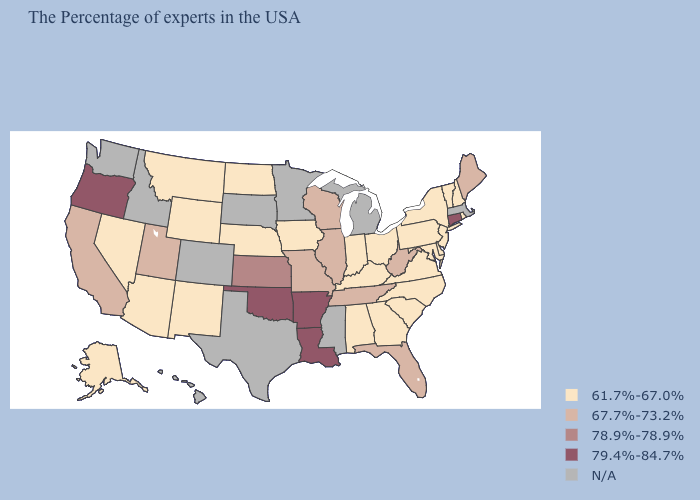Is the legend a continuous bar?
Give a very brief answer. No. Among the states that border Minnesota , does Wisconsin have the highest value?
Answer briefly. Yes. Does the first symbol in the legend represent the smallest category?
Answer briefly. Yes. Among the states that border Illinois , does Indiana have the lowest value?
Short answer required. Yes. Is the legend a continuous bar?
Keep it brief. No. Among the states that border Ohio , does West Virginia have the highest value?
Short answer required. Yes. Does Tennessee have the lowest value in the South?
Short answer required. No. What is the lowest value in states that border South Dakota?
Write a very short answer. 61.7%-67.0%. How many symbols are there in the legend?
Write a very short answer. 5. Among the states that border Iowa , which have the highest value?
Write a very short answer. Wisconsin, Illinois, Missouri. Which states hav the highest value in the West?
Short answer required. Oregon. Name the states that have a value in the range N/A?
Be succinct. Massachusetts, Michigan, Mississippi, Minnesota, Texas, South Dakota, Colorado, Idaho, Washington, Hawaii. What is the lowest value in the West?
Give a very brief answer. 61.7%-67.0%. What is the lowest value in the Northeast?
Short answer required. 61.7%-67.0%. 